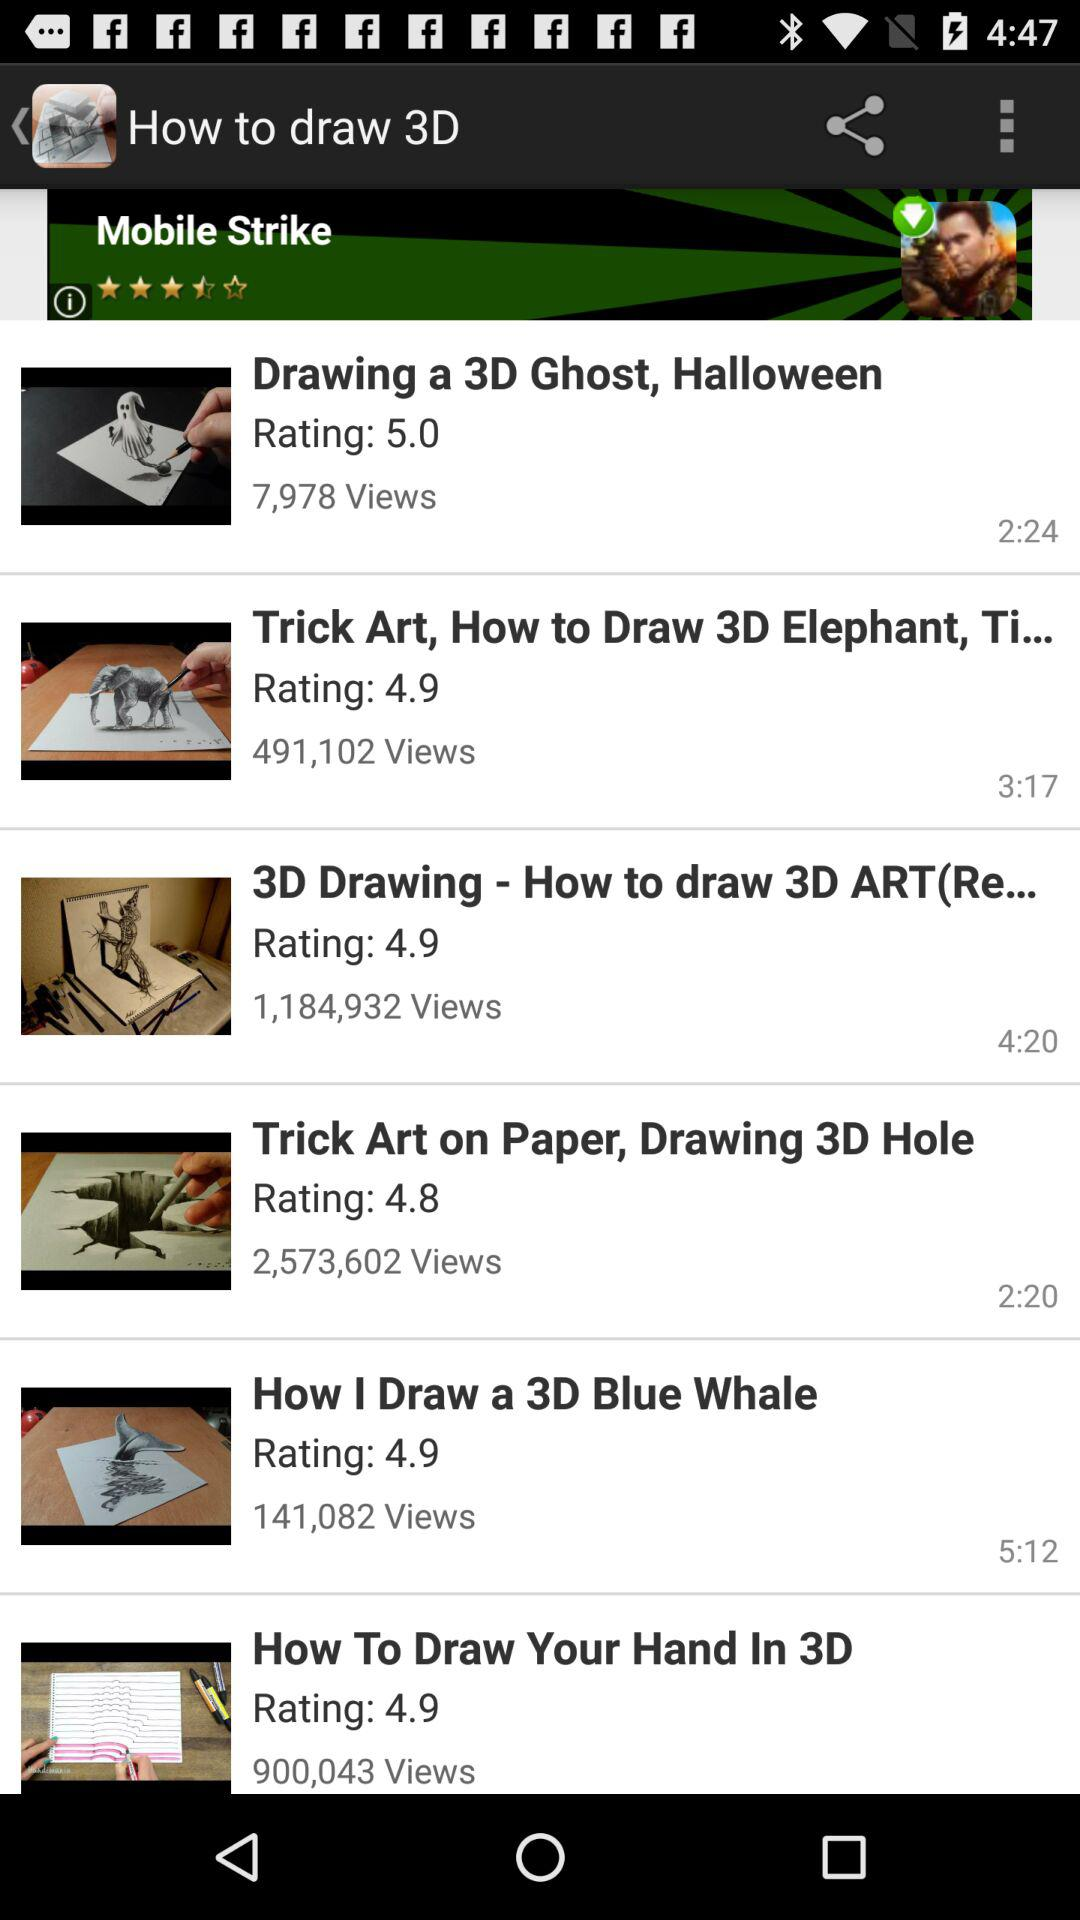How many views are there for "How I Draw a 3D Blue Whale"? There are 141,082 views. 